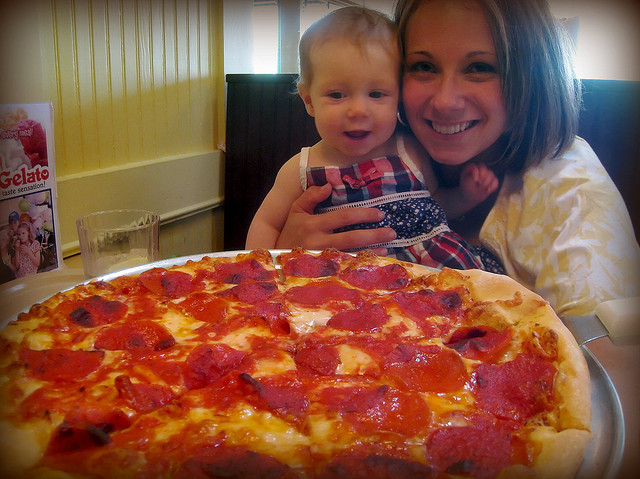Extract all visible text content from this image. Gelato 